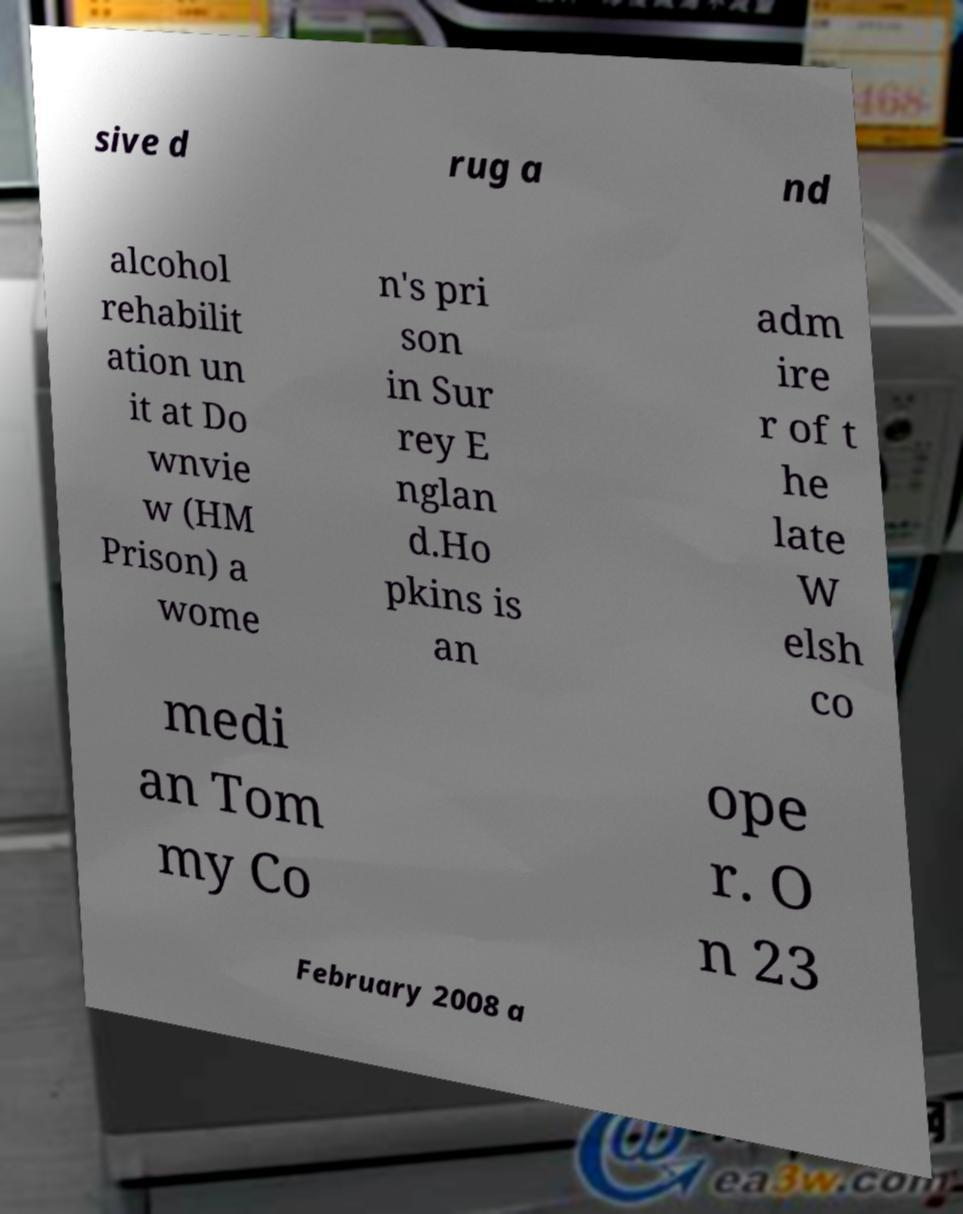Can you accurately transcribe the text from the provided image for me? sive d rug a nd alcohol rehabilit ation un it at Do wnvie w (HM Prison) a wome n's pri son in Sur rey E nglan d.Ho pkins is an adm ire r of t he late W elsh co medi an Tom my Co ope r. O n 23 February 2008 a 